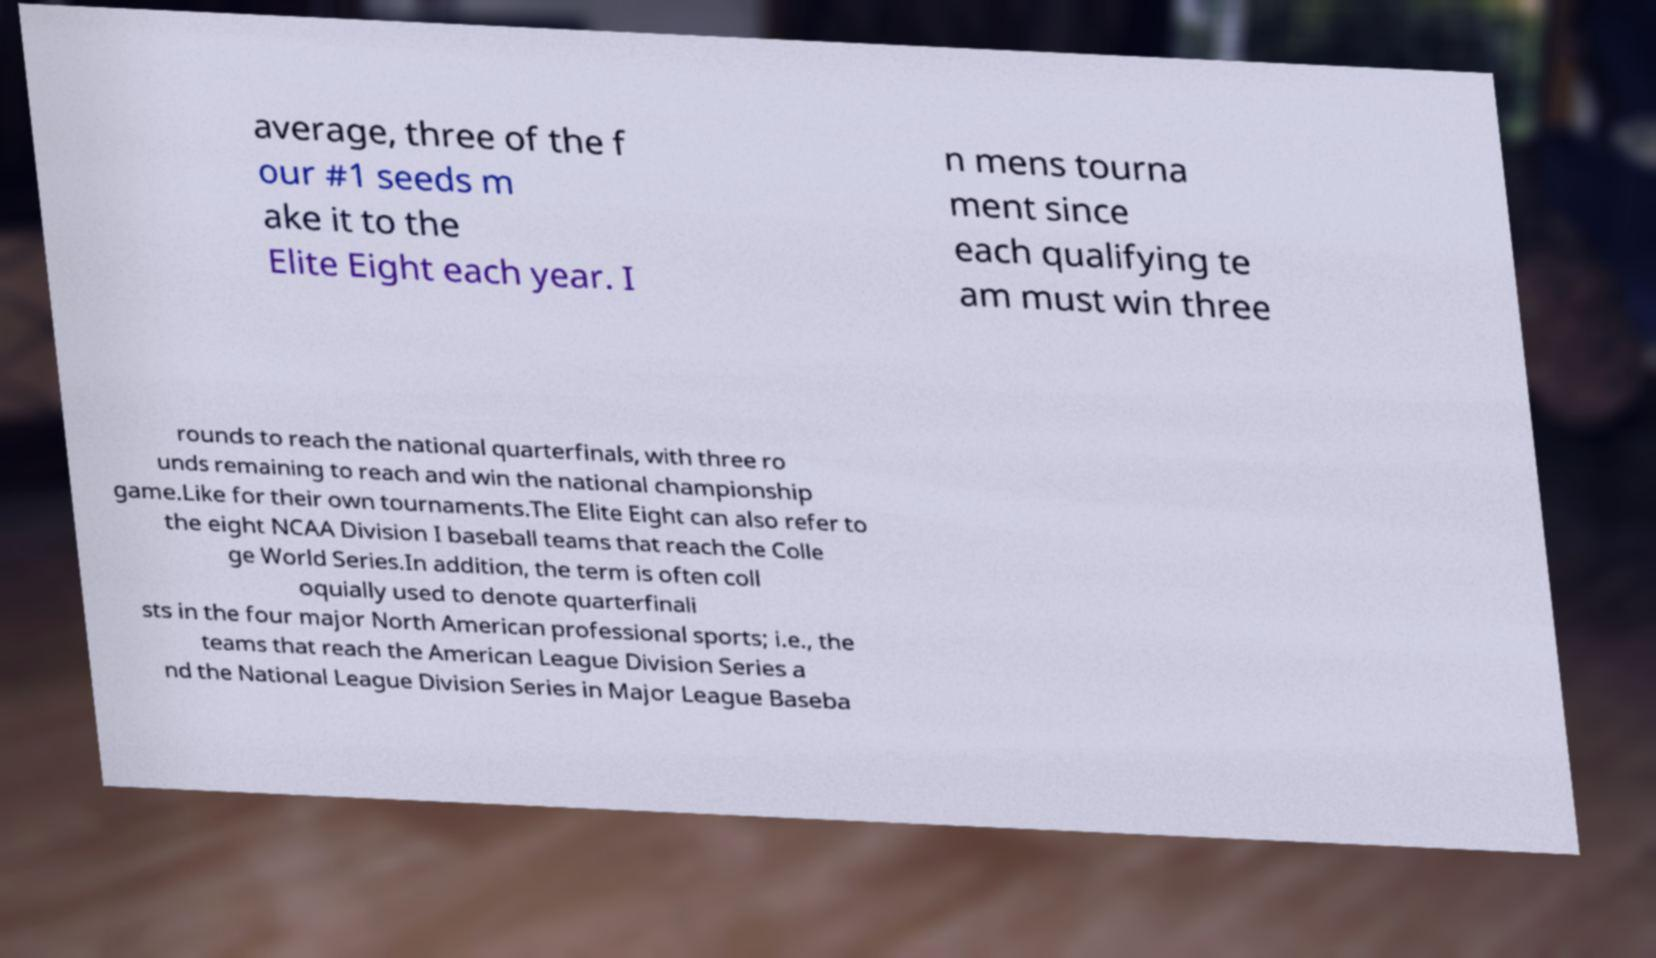There's text embedded in this image that I need extracted. Can you transcribe it verbatim? average, three of the f our #1 seeds m ake it to the Elite Eight each year. I n mens tourna ment since each qualifying te am must win three rounds to reach the national quarterfinals, with three ro unds remaining to reach and win the national championship game.Like for their own tournaments.The Elite Eight can also refer to the eight NCAA Division I baseball teams that reach the Colle ge World Series.In addition, the term is often coll oquially used to denote quarterfinali sts in the four major North American professional sports; i.e., the teams that reach the American League Division Series a nd the National League Division Series in Major League Baseba 